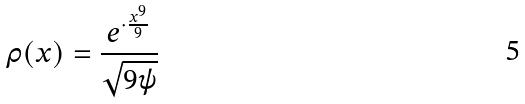Convert formula to latex. <formula><loc_0><loc_0><loc_500><loc_500>\rho ( x ) = \frac { e ^ { \cdot \frac { x ^ { 9 } } { 9 } } } { \sqrt { 9 \psi } }</formula> 